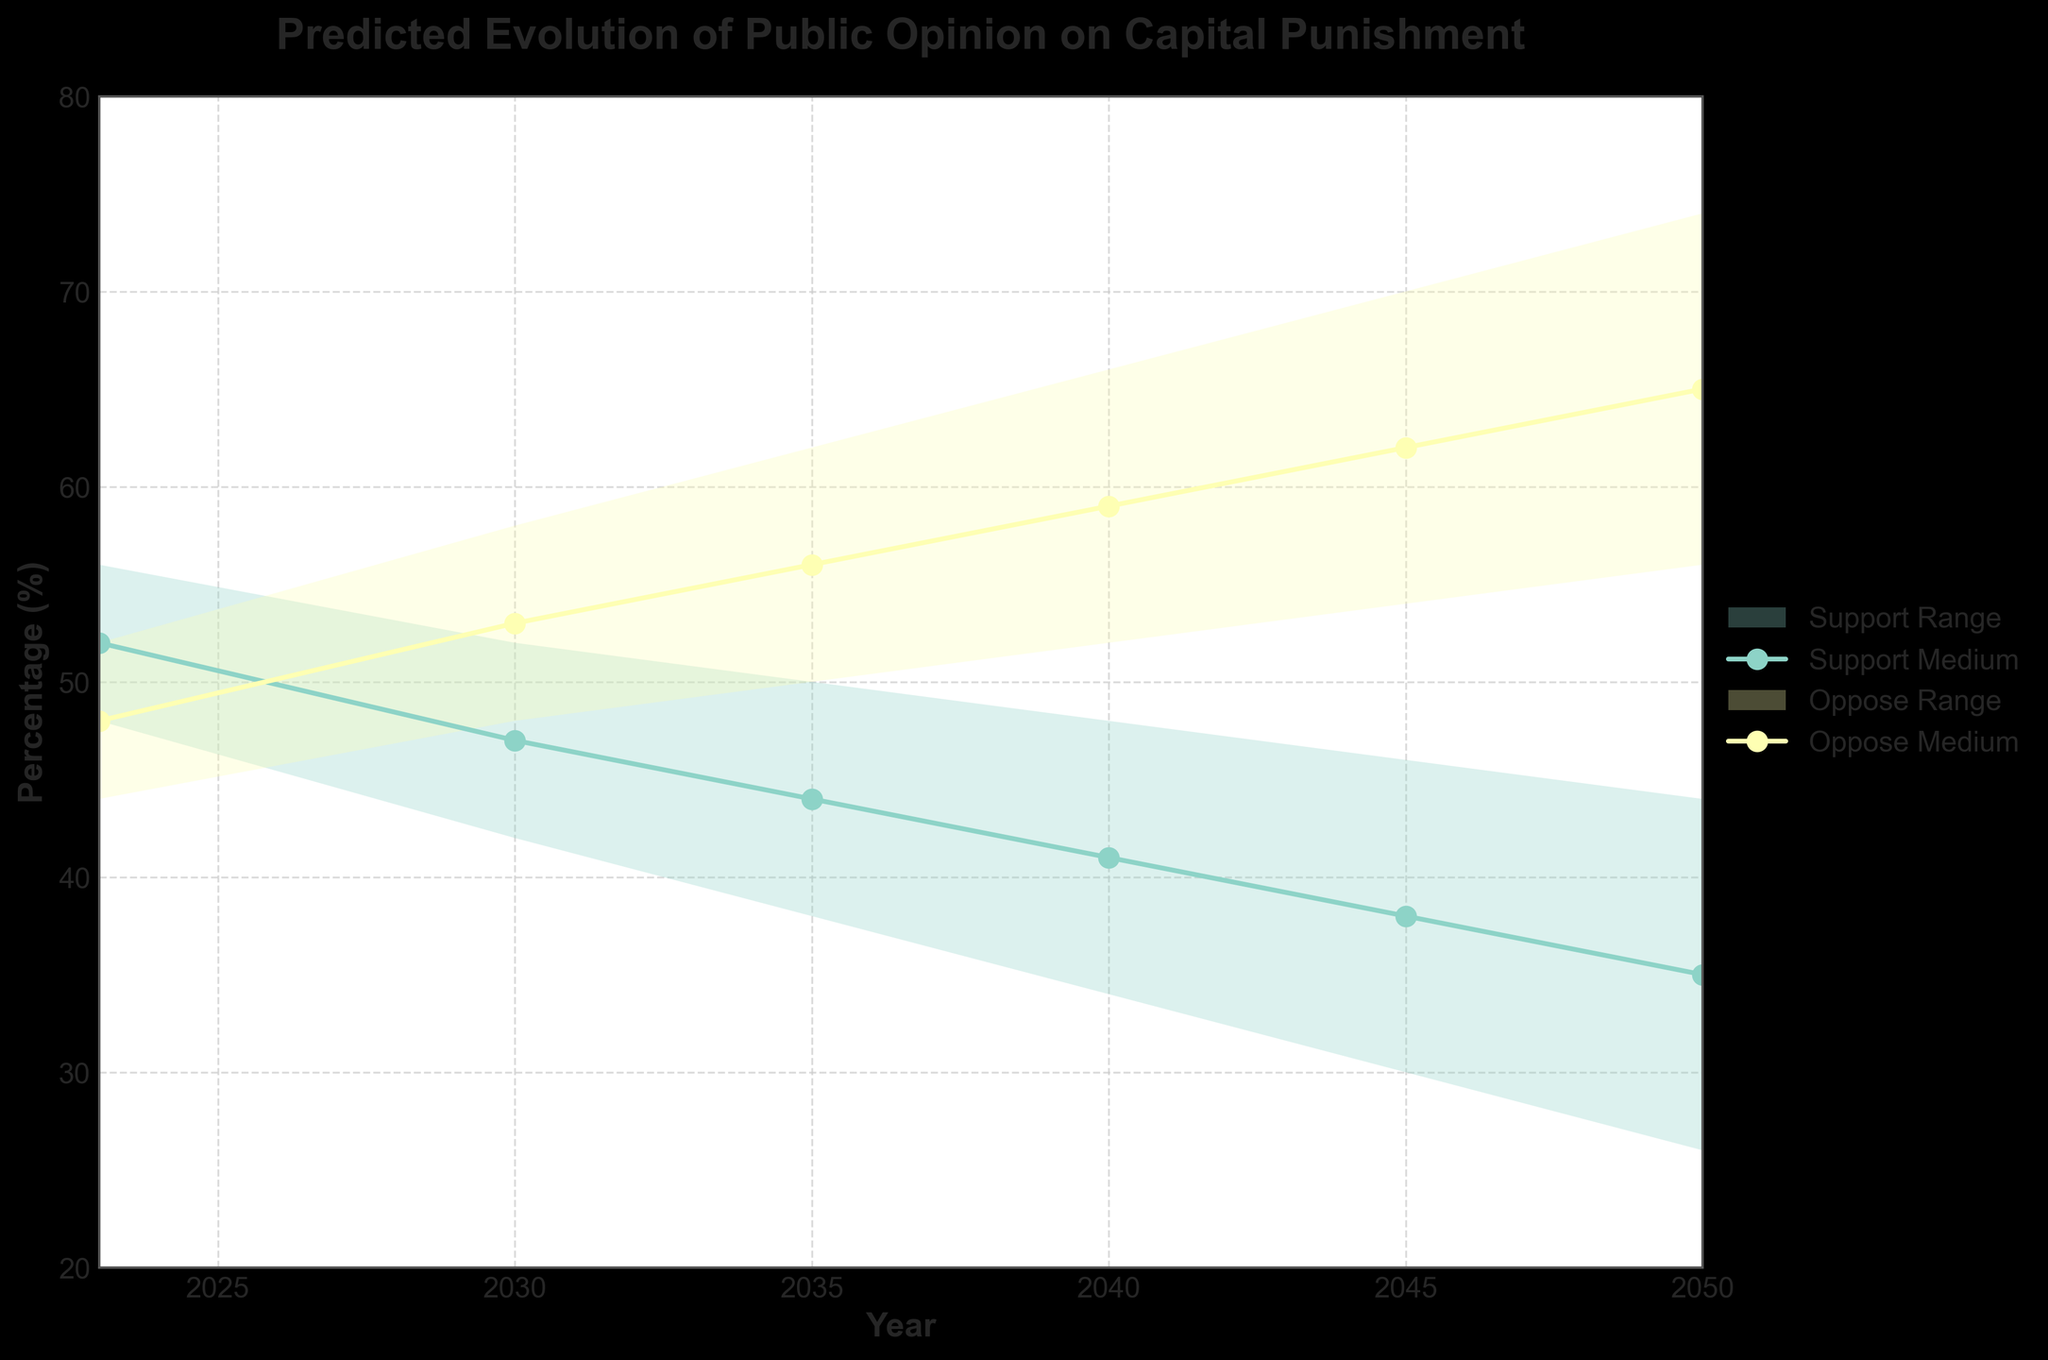What is the title of the figure? The title is typically located at the top of the figure.
Answer: Predicted Evolution of Public Opinion on Capital Punishment What is the predicted median support for capital punishment in 2030? The median support for each year can be found by looking at the "Support_Medium" line for 2030.
Answer: 47% How does the median opposition to capital punishment change from 2023 to 2050? To determine this, compare the "Oppose_Medium" values for 2023 and 2050. In 2023, it is 48%, and in 2050, it is 65%.
Answer: Increases by 17% In which year does the lower bound of support for capital punishment fall below 40%? The lower bound can be found in the "Support_Low" column. Reviewing the data shows that in 2035, it is 38%.
Answer: 2035 What is the range of opposition to capital punishment in 2045? The range of opposition is the difference between "Oppose_High" and "Oppose_Low" in 2045.
Answer: 70% - 54% = 16% How does the range of support for capital punishment change from 2023 to 2050? Calculate the range of support by subtracting "Support_Low" from "Support_High" for both years and compare them. In 2023, the range is 8%, and in 2050, it is 18%.
Answer: Increases by 10% By how much does the predicted median support for capital punishment decrease from 2023 to 2035? Compare the "Support_Medium" values for 2023 and 2035. For 2023, it is 52%, and for 2035, it is 44%.
Answer: Decreases by 8% Which year has the highest predicted upper bound of opposition to capital punishment, and what is that value? The highest predicted upper bound can be found in the "Oppose_High" column. Reviewing the data shows that in 2050, it is 74%.
Answer: 2050, 74% What is the average predicted support for capital punishment in 2040 based on the range provided? The average is calculated by summing "Support_Low", "Support_Medium", and "Support_High" for 2040 and dividing by 3. (34 + 41 + 48) / 3
Answer: 41% What trends do you observe in the confidence intervals for both support and opposition to capital punishment over the years? The confidence intervals, represented by the range between low and high values, appear to widen over the years for both support and opposition, indicating increasing uncertainty.
Answer: Widening over time 